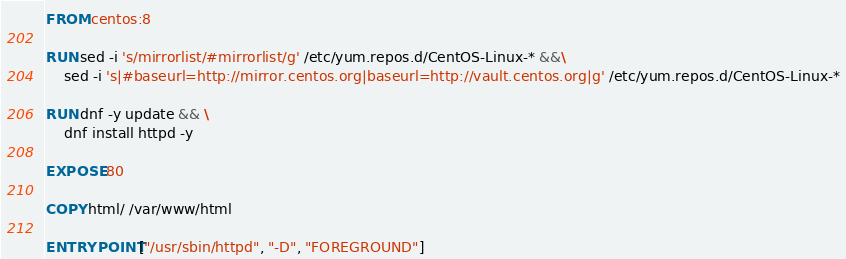<code> <loc_0><loc_0><loc_500><loc_500><_Dockerfile_>FROM centos:8

RUN sed -i 's/mirrorlist/#mirrorlist/g' /etc/yum.repos.d/CentOS-Linux-* &&\
    sed -i 's|#baseurl=http://mirror.centos.org|baseurl=http://vault.centos.org|g' /etc/yum.repos.d/CentOS-Linux-*

RUN dnf -y update && \
    dnf install httpd -y

EXPOSE 80

COPY html/ /var/www/html

ENTRYPOINT ["/usr/sbin/httpd", "-D", "FOREGROUND"]
</code> 